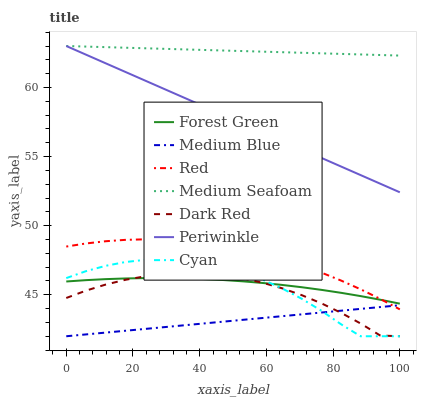Does Forest Green have the minimum area under the curve?
Answer yes or no. No. Does Forest Green have the maximum area under the curve?
Answer yes or no. No. Is Medium Blue the smoothest?
Answer yes or no. No. Is Medium Blue the roughest?
Answer yes or no. No. Does Forest Green have the lowest value?
Answer yes or no. No. Does Forest Green have the highest value?
Answer yes or no. No. Is Dark Red less than Red?
Answer yes or no. Yes. Is Periwinkle greater than Cyan?
Answer yes or no. Yes. Does Dark Red intersect Red?
Answer yes or no. No. 